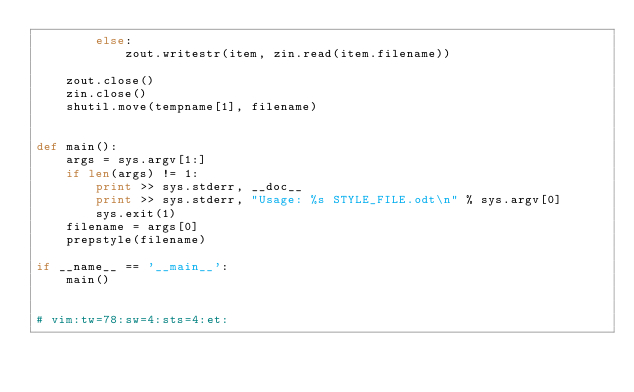Convert code to text. <code><loc_0><loc_0><loc_500><loc_500><_Python_>        else:
            zout.writestr(item, zin.read(item.filename))
    
    zout.close()
    zin.close()
    shutil.move(tempname[1], filename)


def main():
    args = sys.argv[1:]
    if len(args) != 1:
        print >> sys.stderr, __doc__
        print >> sys.stderr, "Usage: %s STYLE_FILE.odt\n" % sys.argv[0]
        sys.exit(1)
    filename = args[0]
    prepstyle(filename)

if __name__ == '__main__':
    main()


# vim:tw=78:sw=4:sts=4:et:
</code> 